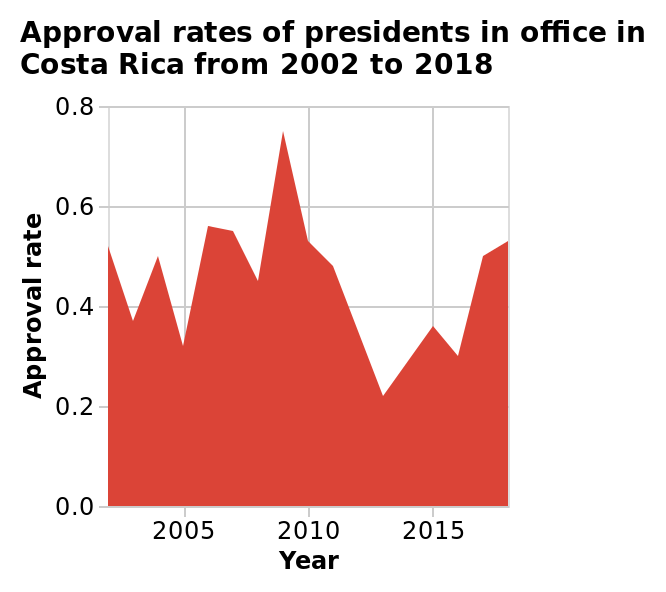<image>
In which year were the approval rates at their lowest point?  The approval rates were at their lowest point in 2013. What does the area plot represent?  The area plot represents the approval rates of presidents in office in Costa Rica from 2002 to 2018. In which country did the approval rates of presidents in office take place? The approval rates of presidents in office took place in Costa Rica. 